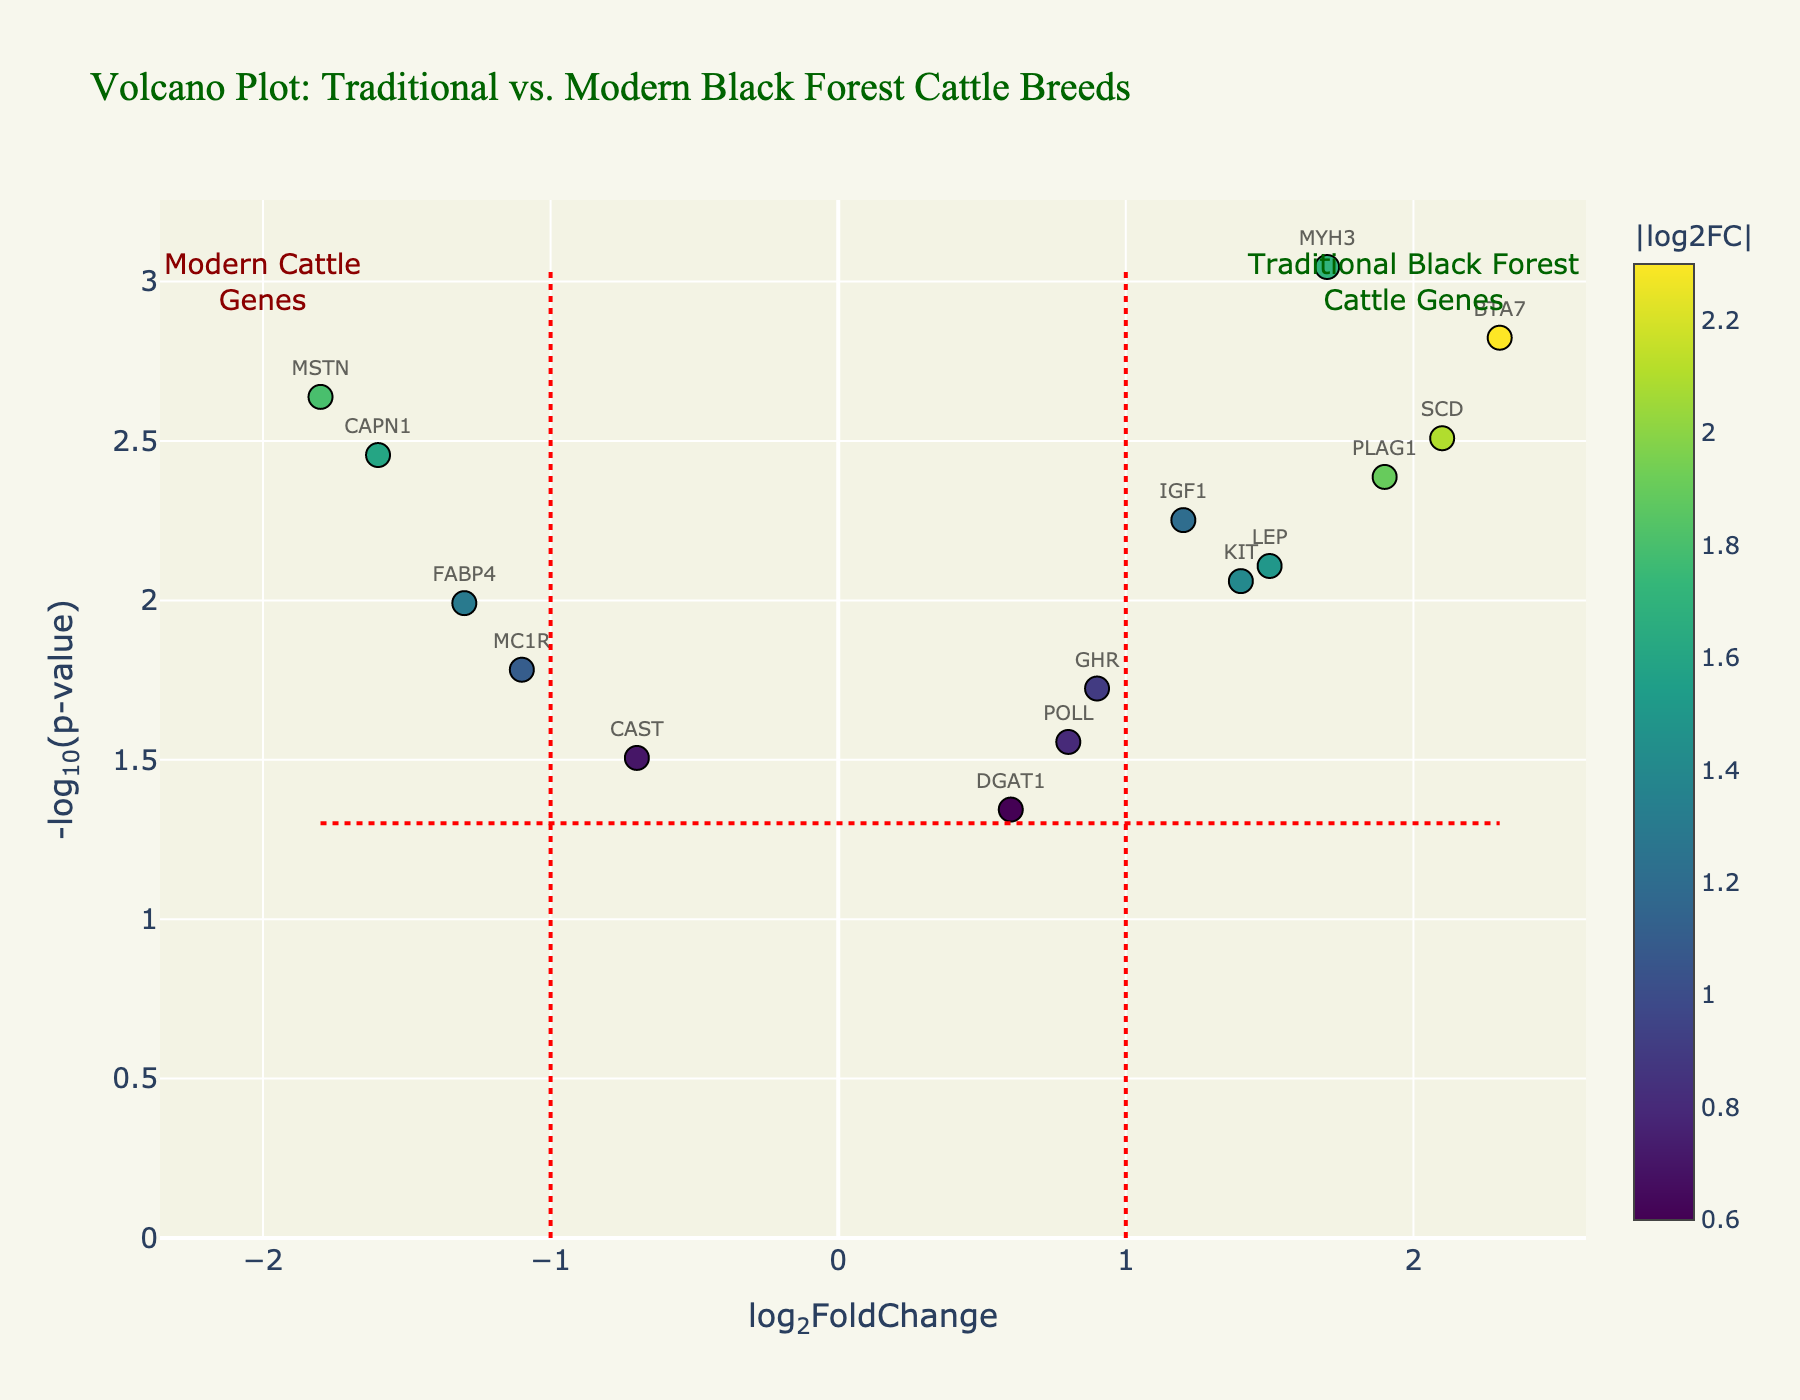What is the title of the plot? The title can be found at the top of the plot, and it is "Volcano Plot: Traditional vs. Modern Black Forest Cattle Breeds".
Answer: Volcano Plot: Traditional vs. Modern Black Forest Cattle Breeds How many data points are shown in the plot? Count all the markers representing genes in the scatter plot. There are 15 genes in the dataset, which equates to 15 data points.
Answer: 15 Which gene has the highest log2FoldChange value? Locate the gene corresponding to the highest value on the x-axis. The gene with the highest log2FoldChange value is BTA7, at 2.3.
Answer: BTA7 Which gene is located at approximately (1.7, 3.0) on the plot? Find the coordinates (1.7, 3.0) by referencing the x and y-axes. The gene at this location is MYH3.
Answer: MYH3 How many genes have a log2FoldChange greater than 1 and a p-value less than 0.01? Look for data points to the right of the vertical red line at x = 1 and above the horizontal red line indicating -log(0.01). There are 4 genes, BTA7, MYH3, SCD, and PLAG1.
Answer: 4 Which gene is closest to the point (0, 1)? Find the data points around (0, 1) on the plot. The closest gene to this point is DGAT1.
Answer: DGAT1 What is the significance threshold for the p-value in the plot? Locate the horizontal red line, which represents the p-value threshold converted to -log10 scale. It's at -log10(0.05). The threshold p-value is 0.05.
Answer: 0.05 Which gene has the second most significant p-value? The second most significant p-value corresponds to the second highest value on the y-axis, which is for the gene SCD.
Answer: SCD What are the log2FoldChange and p-value for gene LEP? Locate the data point for LEP and reference the hover text or axes values. LEP has a log2FoldChange of 1.5 and a p-value of 0.0078.
Answer: log2FoldChange: 1.5, p-value: 0.0078 